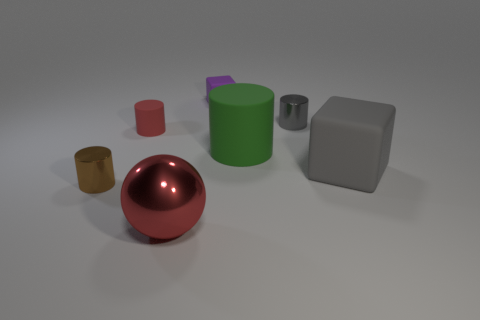Subtract all gray blocks. How many blocks are left? 1 Subtract all tiny red cylinders. How many cylinders are left? 3 Add 1 small yellow rubber objects. How many objects exist? 8 Subtract all spheres. How many objects are left? 6 Subtract 1 cylinders. How many cylinders are left? 3 Subtract all yellow cylinders. Subtract all purple spheres. How many cylinders are left? 4 Subtract all blue cubes. How many red cylinders are left? 1 Subtract all gray cylinders. Subtract all purple cubes. How many objects are left? 5 Add 6 rubber things. How many rubber things are left? 10 Add 1 big green rubber things. How many big green rubber things exist? 2 